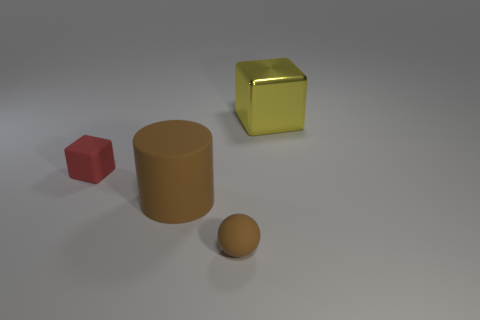Add 1 brown rubber cylinders. How many objects exist? 5 Subtract all cylinders. How many objects are left? 3 Subtract 1 brown balls. How many objects are left? 3 Subtract all large yellow matte cylinders. Subtract all large yellow blocks. How many objects are left? 3 Add 1 large brown matte things. How many large brown matte things are left? 2 Add 4 small gray shiny cubes. How many small gray shiny cubes exist? 4 